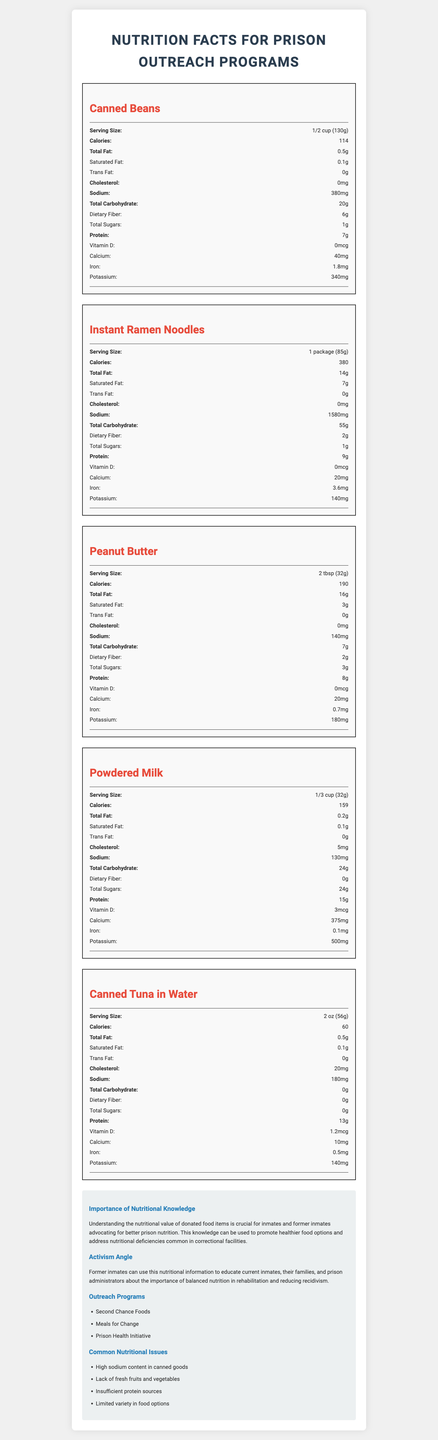what is the serving size for canned beans? The serving size for canned beans is listed directly within the "Canned Beans" section of the nutrition label.
Answer: 1/2 cup (130g) How much sodium is in one package of Instant Ramen Noodles? The nutrition label for Instant Ramen Noodles specifies that it contains 1580 mg of sodium.
Answer: 1580 mg What is the protein content in powdered milk? The protein content for powdered milk is mentioned directly in the nutrition label section, showing 15g per serving.
Answer: 15g How much calcium is in a serving of canned tuna in water? The calcium content for canned tuna in water is listed as 10 mg per serving in the nutrition label section.
Answer: 10 mg What is the total fat content in peanut butter? The total fat content in peanut butter is mentioned as 16g per serving in the nutrition label section.
Answer: 16g Which food item has the highest iron content? A. Canned Beans B. Instant Ramen Noodles C. Peanut Butter Instant Ramen Noodles contain 3.6 mg of iron, which is higher than the iron content in canned beans (1.8 mg) and peanut butter (0.7 mg).
Answer: B How much total carbohydrate is in one serving of canned beans? The total carbohydrate content in canned beans is listed as 20g per serving in the nutrition label.
Answer: 20g What is the serving size for powdered milk? A. 1/2 cup (130g) B. 1 package (85g) C. 1/3 cup (32g) The serving size for powdered milk is specified as 1/3 cup (32g) in the nutrition label.
Answer: C Does canned tuna in water contain any dietary fiber? The nutrition label for canned tuna in water shows that it contains 0g dietary fiber.
Answer: No Summarize the importance of the information provided in this document. The document provides detailed nutritional facts for various food items like canned beans, instant ramen noodles, peanut butter, powdered milk, and canned tuna. Additionally, it discusses the importance of this information for former inmates who aim to use their lived experiences for activism, particularly in promoting better nutrition in prisons.
Answer: It is crucial for understanding the nutritional value of food items commonly donated to prison outreach programs. This knowledge can be used by former inmates to advocate for healthier food options and address nutritional deficiencies within correctional facilities, thereby promoting better overall health and aiding in rehabilitation efforts. Which food item has the lowest potassium content? Comparing all food items, Instant Ramen Noodles have the lowest potassium content at 140 mg.
Answer: Instant Ramen Noodles Is there enough information in the document to find out the recommended daily intake of sodium? The document does not provide recommended daily intake values; it only provides the sodium content for each food item.
Answer: Not enough information What is a common nutritional issue mentioned in the document? The document highlights high sodium content in canned goods as one of the common nutritional issues related to prison food.
Answer: High sodium content in canned goods Which food item has the highest protein content per serving? A. Canned Beans B. Powdered Milk C. Canned Tuna in Water D. Peanut Butter Powdered Milk has the highest protein content per serving at 15 grams.
Answer: B 